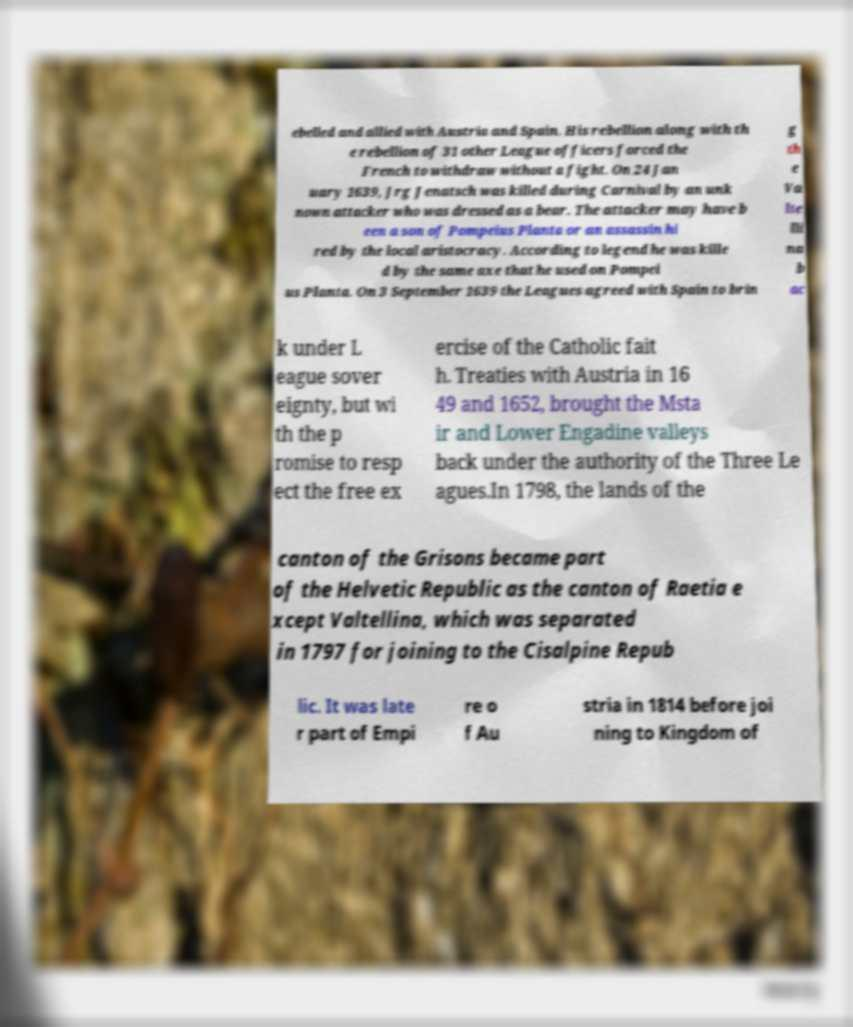Can you read and provide the text displayed in the image?This photo seems to have some interesting text. Can you extract and type it out for me? ebelled and allied with Austria and Spain. His rebellion along with th e rebellion of 31 other League officers forced the French to withdraw without a fight. On 24 Jan uary 1639, Jrg Jenatsch was killed during Carnival by an unk nown attacker who was dressed as a bear. The attacker may have b een a son of Pompeius Planta or an assassin hi red by the local aristocracy. According to legend he was kille d by the same axe that he used on Pompei us Planta. On 3 September 1639 the Leagues agreed with Spain to brin g th e Va lte lli na b ac k under L eague sover eignty, but wi th the p romise to resp ect the free ex ercise of the Catholic fait h. Treaties with Austria in 16 49 and 1652, brought the Msta ir and Lower Engadine valleys back under the authority of the Three Le agues.In 1798, the lands of the canton of the Grisons became part of the Helvetic Republic as the canton of Raetia e xcept Valtellina, which was separated in 1797 for joining to the Cisalpine Repub lic. It was late r part of Empi re o f Au stria in 1814 before joi ning to Kingdom of 